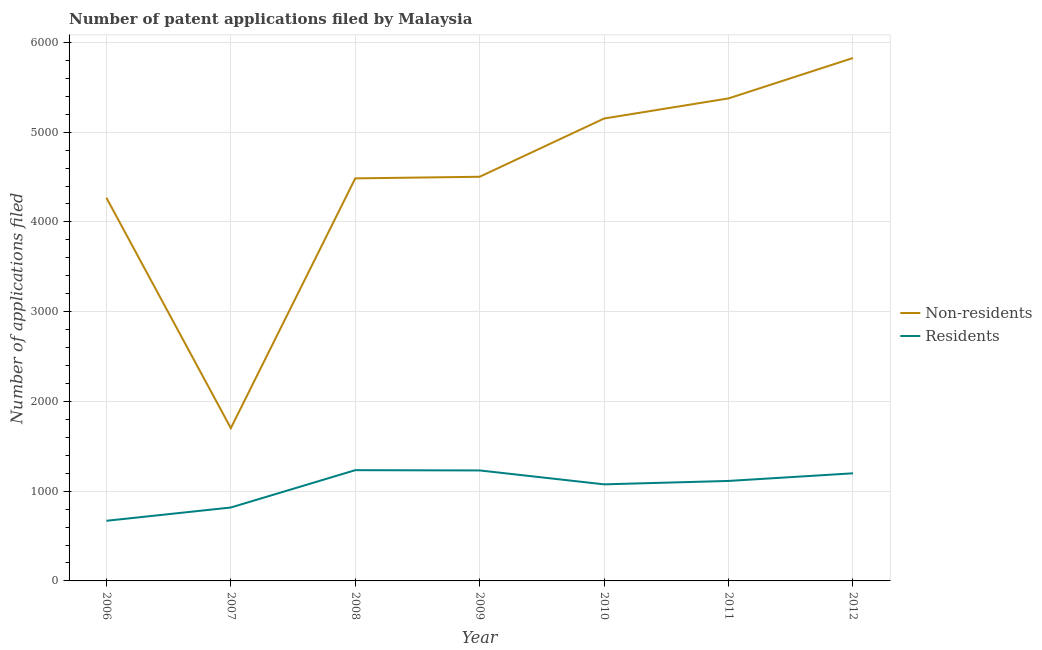What is the number of patent applications by residents in 2009?
Offer a very short reply. 1231. Across all years, what is the maximum number of patent applications by non residents?
Your response must be concise. 5826. Across all years, what is the minimum number of patent applications by non residents?
Make the answer very short. 1702. In which year was the number of patent applications by non residents minimum?
Keep it short and to the point. 2007. What is the total number of patent applications by residents in the graph?
Make the answer very short. 7342. What is the difference between the number of patent applications by residents in 2010 and that in 2011?
Give a very brief answer. -38. What is the difference between the number of patent applications by residents in 2008 and the number of patent applications by non residents in 2012?
Your answer should be compact. -4592. What is the average number of patent applications by residents per year?
Your answer should be very brief. 1048.86. In the year 2008, what is the difference between the number of patent applications by residents and number of patent applications by non residents?
Provide a short and direct response. -3251. What is the ratio of the number of patent applications by residents in 2008 to that in 2009?
Provide a short and direct response. 1. What is the difference between the highest and the second highest number of patent applications by non residents?
Make the answer very short. 450. What is the difference between the highest and the lowest number of patent applications by residents?
Ensure brevity in your answer.  564. Does the number of patent applications by residents monotonically increase over the years?
Make the answer very short. No. What is the difference between two consecutive major ticks on the Y-axis?
Provide a succinct answer. 1000. Does the graph contain any zero values?
Your answer should be compact. No. How many legend labels are there?
Provide a short and direct response. 2. How are the legend labels stacked?
Offer a terse response. Vertical. What is the title of the graph?
Provide a short and direct response. Number of patent applications filed by Malaysia. Does "Resident" appear as one of the legend labels in the graph?
Keep it short and to the point. No. What is the label or title of the Y-axis?
Provide a short and direct response. Number of applications filed. What is the Number of applications filed in Non-residents in 2006?
Your answer should be compact. 4269. What is the Number of applications filed of Residents in 2006?
Ensure brevity in your answer.  670. What is the Number of applications filed in Non-residents in 2007?
Offer a terse response. 1702. What is the Number of applications filed of Residents in 2007?
Ensure brevity in your answer.  818. What is the Number of applications filed in Non-residents in 2008?
Provide a succinct answer. 4485. What is the Number of applications filed in Residents in 2008?
Keep it short and to the point. 1234. What is the Number of applications filed of Non-residents in 2009?
Provide a succinct answer. 4503. What is the Number of applications filed in Residents in 2009?
Offer a terse response. 1231. What is the Number of applications filed in Non-residents in 2010?
Give a very brief answer. 5152. What is the Number of applications filed in Residents in 2010?
Make the answer very short. 1076. What is the Number of applications filed in Non-residents in 2011?
Your answer should be very brief. 5376. What is the Number of applications filed of Residents in 2011?
Your answer should be compact. 1114. What is the Number of applications filed in Non-residents in 2012?
Make the answer very short. 5826. What is the Number of applications filed in Residents in 2012?
Offer a terse response. 1199. Across all years, what is the maximum Number of applications filed of Non-residents?
Provide a short and direct response. 5826. Across all years, what is the maximum Number of applications filed of Residents?
Make the answer very short. 1234. Across all years, what is the minimum Number of applications filed in Non-residents?
Offer a very short reply. 1702. Across all years, what is the minimum Number of applications filed in Residents?
Make the answer very short. 670. What is the total Number of applications filed of Non-residents in the graph?
Ensure brevity in your answer.  3.13e+04. What is the total Number of applications filed of Residents in the graph?
Your answer should be very brief. 7342. What is the difference between the Number of applications filed of Non-residents in 2006 and that in 2007?
Your response must be concise. 2567. What is the difference between the Number of applications filed of Residents in 2006 and that in 2007?
Keep it short and to the point. -148. What is the difference between the Number of applications filed of Non-residents in 2006 and that in 2008?
Make the answer very short. -216. What is the difference between the Number of applications filed of Residents in 2006 and that in 2008?
Your response must be concise. -564. What is the difference between the Number of applications filed of Non-residents in 2006 and that in 2009?
Provide a succinct answer. -234. What is the difference between the Number of applications filed in Residents in 2006 and that in 2009?
Ensure brevity in your answer.  -561. What is the difference between the Number of applications filed of Non-residents in 2006 and that in 2010?
Provide a short and direct response. -883. What is the difference between the Number of applications filed in Residents in 2006 and that in 2010?
Provide a succinct answer. -406. What is the difference between the Number of applications filed in Non-residents in 2006 and that in 2011?
Your response must be concise. -1107. What is the difference between the Number of applications filed in Residents in 2006 and that in 2011?
Your answer should be very brief. -444. What is the difference between the Number of applications filed in Non-residents in 2006 and that in 2012?
Offer a terse response. -1557. What is the difference between the Number of applications filed in Residents in 2006 and that in 2012?
Make the answer very short. -529. What is the difference between the Number of applications filed of Non-residents in 2007 and that in 2008?
Your answer should be very brief. -2783. What is the difference between the Number of applications filed in Residents in 2007 and that in 2008?
Make the answer very short. -416. What is the difference between the Number of applications filed of Non-residents in 2007 and that in 2009?
Give a very brief answer. -2801. What is the difference between the Number of applications filed of Residents in 2007 and that in 2009?
Your response must be concise. -413. What is the difference between the Number of applications filed in Non-residents in 2007 and that in 2010?
Your answer should be compact. -3450. What is the difference between the Number of applications filed of Residents in 2007 and that in 2010?
Provide a succinct answer. -258. What is the difference between the Number of applications filed of Non-residents in 2007 and that in 2011?
Offer a terse response. -3674. What is the difference between the Number of applications filed in Residents in 2007 and that in 2011?
Your answer should be compact. -296. What is the difference between the Number of applications filed in Non-residents in 2007 and that in 2012?
Keep it short and to the point. -4124. What is the difference between the Number of applications filed in Residents in 2007 and that in 2012?
Ensure brevity in your answer.  -381. What is the difference between the Number of applications filed of Non-residents in 2008 and that in 2010?
Give a very brief answer. -667. What is the difference between the Number of applications filed in Residents in 2008 and that in 2010?
Make the answer very short. 158. What is the difference between the Number of applications filed of Non-residents in 2008 and that in 2011?
Provide a succinct answer. -891. What is the difference between the Number of applications filed of Residents in 2008 and that in 2011?
Ensure brevity in your answer.  120. What is the difference between the Number of applications filed of Non-residents in 2008 and that in 2012?
Your answer should be very brief. -1341. What is the difference between the Number of applications filed of Non-residents in 2009 and that in 2010?
Offer a terse response. -649. What is the difference between the Number of applications filed of Residents in 2009 and that in 2010?
Your answer should be compact. 155. What is the difference between the Number of applications filed in Non-residents in 2009 and that in 2011?
Give a very brief answer. -873. What is the difference between the Number of applications filed in Residents in 2009 and that in 2011?
Keep it short and to the point. 117. What is the difference between the Number of applications filed in Non-residents in 2009 and that in 2012?
Offer a very short reply. -1323. What is the difference between the Number of applications filed of Residents in 2009 and that in 2012?
Ensure brevity in your answer.  32. What is the difference between the Number of applications filed of Non-residents in 2010 and that in 2011?
Make the answer very short. -224. What is the difference between the Number of applications filed in Residents in 2010 and that in 2011?
Offer a terse response. -38. What is the difference between the Number of applications filed of Non-residents in 2010 and that in 2012?
Ensure brevity in your answer.  -674. What is the difference between the Number of applications filed of Residents in 2010 and that in 2012?
Offer a very short reply. -123. What is the difference between the Number of applications filed in Non-residents in 2011 and that in 2012?
Your response must be concise. -450. What is the difference between the Number of applications filed of Residents in 2011 and that in 2012?
Your response must be concise. -85. What is the difference between the Number of applications filed in Non-residents in 2006 and the Number of applications filed in Residents in 2007?
Ensure brevity in your answer.  3451. What is the difference between the Number of applications filed of Non-residents in 2006 and the Number of applications filed of Residents in 2008?
Your answer should be very brief. 3035. What is the difference between the Number of applications filed in Non-residents in 2006 and the Number of applications filed in Residents in 2009?
Offer a terse response. 3038. What is the difference between the Number of applications filed of Non-residents in 2006 and the Number of applications filed of Residents in 2010?
Offer a terse response. 3193. What is the difference between the Number of applications filed in Non-residents in 2006 and the Number of applications filed in Residents in 2011?
Your response must be concise. 3155. What is the difference between the Number of applications filed in Non-residents in 2006 and the Number of applications filed in Residents in 2012?
Ensure brevity in your answer.  3070. What is the difference between the Number of applications filed of Non-residents in 2007 and the Number of applications filed of Residents in 2008?
Make the answer very short. 468. What is the difference between the Number of applications filed in Non-residents in 2007 and the Number of applications filed in Residents in 2009?
Ensure brevity in your answer.  471. What is the difference between the Number of applications filed in Non-residents in 2007 and the Number of applications filed in Residents in 2010?
Your answer should be compact. 626. What is the difference between the Number of applications filed in Non-residents in 2007 and the Number of applications filed in Residents in 2011?
Ensure brevity in your answer.  588. What is the difference between the Number of applications filed in Non-residents in 2007 and the Number of applications filed in Residents in 2012?
Offer a terse response. 503. What is the difference between the Number of applications filed in Non-residents in 2008 and the Number of applications filed in Residents in 2009?
Keep it short and to the point. 3254. What is the difference between the Number of applications filed in Non-residents in 2008 and the Number of applications filed in Residents in 2010?
Ensure brevity in your answer.  3409. What is the difference between the Number of applications filed in Non-residents in 2008 and the Number of applications filed in Residents in 2011?
Keep it short and to the point. 3371. What is the difference between the Number of applications filed in Non-residents in 2008 and the Number of applications filed in Residents in 2012?
Offer a terse response. 3286. What is the difference between the Number of applications filed of Non-residents in 2009 and the Number of applications filed of Residents in 2010?
Offer a very short reply. 3427. What is the difference between the Number of applications filed in Non-residents in 2009 and the Number of applications filed in Residents in 2011?
Provide a short and direct response. 3389. What is the difference between the Number of applications filed of Non-residents in 2009 and the Number of applications filed of Residents in 2012?
Your answer should be compact. 3304. What is the difference between the Number of applications filed in Non-residents in 2010 and the Number of applications filed in Residents in 2011?
Your answer should be compact. 4038. What is the difference between the Number of applications filed in Non-residents in 2010 and the Number of applications filed in Residents in 2012?
Your answer should be very brief. 3953. What is the difference between the Number of applications filed of Non-residents in 2011 and the Number of applications filed of Residents in 2012?
Provide a succinct answer. 4177. What is the average Number of applications filed of Non-residents per year?
Your answer should be very brief. 4473.29. What is the average Number of applications filed of Residents per year?
Provide a succinct answer. 1048.86. In the year 2006, what is the difference between the Number of applications filed in Non-residents and Number of applications filed in Residents?
Your answer should be compact. 3599. In the year 2007, what is the difference between the Number of applications filed of Non-residents and Number of applications filed of Residents?
Ensure brevity in your answer.  884. In the year 2008, what is the difference between the Number of applications filed of Non-residents and Number of applications filed of Residents?
Offer a very short reply. 3251. In the year 2009, what is the difference between the Number of applications filed of Non-residents and Number of applications filed of Residents?
Your answer should be very brief. 3272. In the year 2010, what is the difference between the Number of applications filed of Non-residents and Number of applications filed of Residents?
Your answer should be very brief. 4076. In the year 2011, what is the difference between the Number of applications filed in Non-residents and Number of applications filed in Residents?
Provide a succinct answer. 4262. In the year 2012, what is the difference between the Number of applications filed of Non-residents and Number of applications filed of Residents?
Your response must be concise. 4627. What is the ratio of the Number of applications filed in Non-residents in 2006 to that in 2007?
Your answer should be very brief. 2.51. What is the ratio of the Number of applications filed in Residents in 2006 to that in 2007?
Make the answer very short. 0.82. What is the ratio of the Number of applications filed in Non-residents in 2006 to that in 2008?
Offer a very short reply. 0.95. What is the ratio of the Number of applications filed of Residents in 2006 to that in 2008?
Your answer should be compact. 0.54. What is the ratio of the Number of applications filed of Non-residents in 2006 to that in 2009?
Provide a short and direct response. 0.95. What is the ratio of the Number of applications filed in Residents in 2006 to that in 2009?
Your answer should be compact. 0.54. What is the ratio of the Number of applications filed in Non-residents in 2006 to that in 2010?
Offer a terse response. 0.83. What is the ratio of the Number of applications filed in Residents in 2006 to that in 2010?
Provide a succinct answer. 0.62. What is the ratio of the Number of applications filed in Non-residents in 2006 to that in 2011?
Provide a short and direct response. 0.79. What is the ratio of the Number of applications filed of Residents in 2006 to that in 2011?
Provide a succinct answer. 0.6. What is the ratio of the Number of applications filed of Non-residents in 2006 to that in 2012?
Provide a short and direct response. 0.73. What is the ratio of the Number of applications filed of Residents in 2006 to that in 2012?
Provide a succinct answer. 0.56. What is the ratio of the Number of applications filed of Non-residents in 2007 to that in 2008?
Offer a very short reply. 0.38. What is the ratio of the Number of applications filed in Residents in 2007 to that in 2008?
Your answer should be compact. 0.66. What is the ratio of the Number of applications filed of Non-residents in 2007 to that in 2009?
Keep it short and to the point. 0.38. What is the ratio of the Number of applications filed of Residents in 2007 to that in 2009?
Ensure brevity in your answer.  0.66. What is the ratio of the Number of applications filed in Non-residents in 2007 to that in 2010?
Provide a succinct answer. 0.33. What is the ratio of the Number of applications filed of Residents in 2007 to that in 2010?
Your response must be concise. 0.76. What is the ratio of the Number of applications filed of Non-residents in 2007 to that in 2011?
Your answer should be compact. 0.32. What is the ratio of the Number of applications filed of Residents in 2007 to that in 2011?
Offer a terse response. 0.73. What is the ratio of the Number of applications filed in Non-residents in 2007 to that in 2012?
Your answer should be compact. 0.29. What is the ratio of the Number of applications filed in Residents in 2007 to that in 2012?
Offer a very short reply. 0.68. What is the ratio of the Number of applications filed in Non-residents in 2008 to that in 2009?
Offer a very short reply. 1. What is the ratio of the Number of applications filed in Non-residents in 2008 to that in 2010?
Your answer should be very brief. 0.87. What is the ratio of the Number of applications filed in Residents in 2008 to that in 2010?
Make the answer very short. 1.15. What is the ratio of the Number of applications filed of Non-residents in 2008 to that in 2011?
Your answer should be compact. 0.83. What is the ratio of the Number of applications filed in Residents in 2008 to that in 2011?
Make the answer very short. 1.11. What is the ratio of the Number of applications filed of Non-residents in 2008 to that in 2012?
Provide a short and direct response. 0.77. What is the ratio of the Number of applications filed in Residents in 2008 to that in 2012?
Provide a short and direct response. 1.03. What is the ratio of the Number of applications filed in Non-residents in 2009 to that in 2010?
Give a very brief answer. 0.87. What is the ratio of the Number of applications filed in Residents in 2009 to that in 2010?
Give a very brief answer. 1.14. What is the ratio of the Number of applications filed in Non-residents in 2009 to that in 2011?
Make the answer very short. 0.84. What is the ratio of the Number of applications filed in Residents in 2009 to that in 2011?
Offer a very short reply. 1.1. What is the ratio of the Number of applications filed in Non-residents in 2009 to that in 2012?
Offer a very short reply. 0.77. What is the ratio of the Number of applications filed in Residents in 2009 to that in 2012?
Your response must be concise. 1.03. What is the ratio of the Number of applications filed in Residents in 2010 to that in 2011?
Your answer should be very brief. 0.97. What is the ratio of the Number of applications filed in Non-residents in 2010 to that in 2012?
Provide a short and direct response. 0.88. What is the ratio of the Number of applications filed of Residents in 2010 to that in 2012?
Provide a succinct answer. 0.9. What is the ratio of the Number of applications filed in Non-residents in 2011 to that in 2012?
Give a very brief answer. 0.92. What is the ratio of the Number of applications filed in Residents in 2011 to that in 2012?
Offer a terse response. 0.93. What is the difference between the highest and the second highest Number of applications filed in Non-residents?
Your answer should be compact. 450. What is the difference between the highest and the second highest Number of applications filed of Residents?
Provide a succinct answer. 3. What is the difference between the highest and the lowest Number of applications filed of Non-residents?
Give a very brief answer. 4124. What is the difference between the highest and the lowest Number of applications filed in Residents?
Provide a succinct answer. 564. 